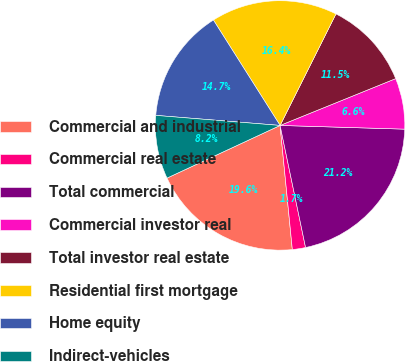Convert chart to OTSL. <chart><loc_0><loc_0><loc_500><loc_500><pie_chart><fcel>Commercial and industrial<fcel>Commercial real estate<fcel>Total commercial<fcel>Commercial investor real<fcel>Total investor real estate<fcel>Residential first mortgage<fcel>Home equity<fcel>Indirect-vehicles<nl><fcel>19.63%<fcel>1.71%<fcel>21.25%<fcel>6.6%<fcel>11.48%<fcel>16.37%<fcel>14.74%<fcel>8.22%<nl></chart> 